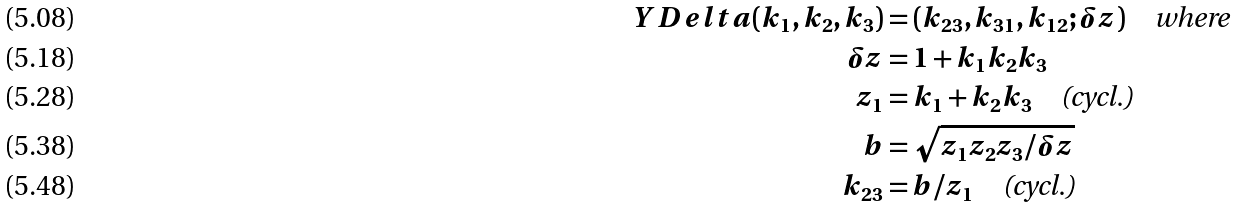<formula> <loc_0><loc_0><loc_500><loc_500>Y D e l t a ( k _ { 1 } , k _ { 2 } , k _ { 3 } ) & = ( k _ { 2 3 } , k _ { 3 1 } , k _ { 1 2 } ; \delta z ) \quad \text {where} \\ \delta z & = 1 + k _ { 1 } k _ { 2 } k _ { 3 } \\ z _ { 1 } & = k _ { 1 } + k _ { 2 } k _ { 3 } \quad \text {(cycl.)} \\ b & = \sqrt { z _ { 1 } z _ { 2 } z _ { 3 } / \delta z } \\ k _ { 2 3 } & = b / z _ { 1 } \quad \text {(cycl.)}</formula> 